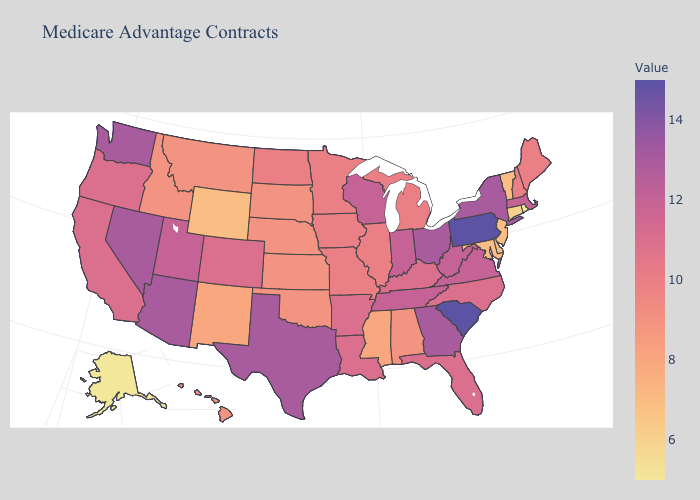Is the legend a continuous bar?
Short answer required. Yes. 